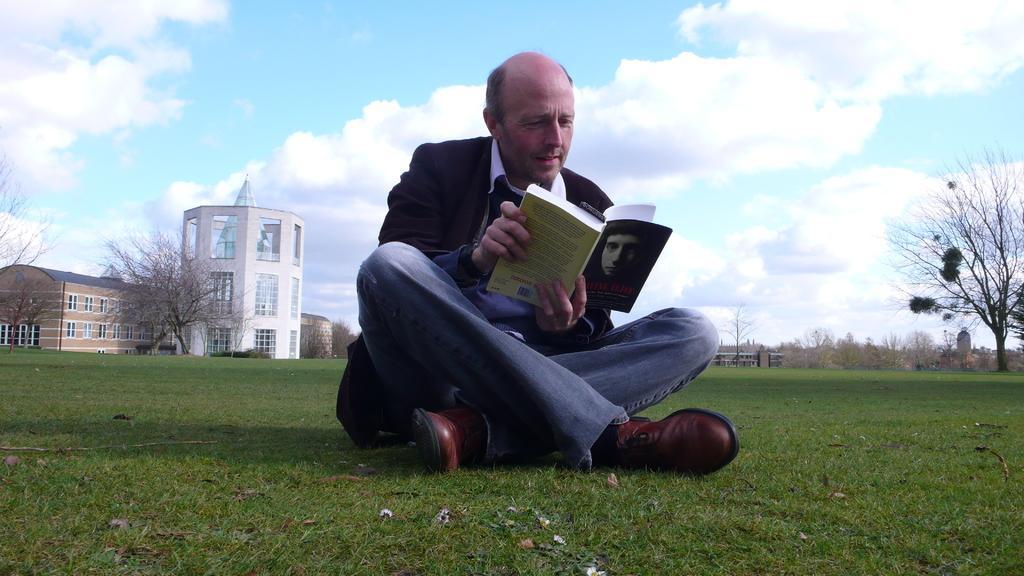Please provide a concise description of this image. In this image I can see a person wearing white, black and blue colored dress is sitting on the ground and holding a book. In the background I can see few buildings, few trees and the sky. 